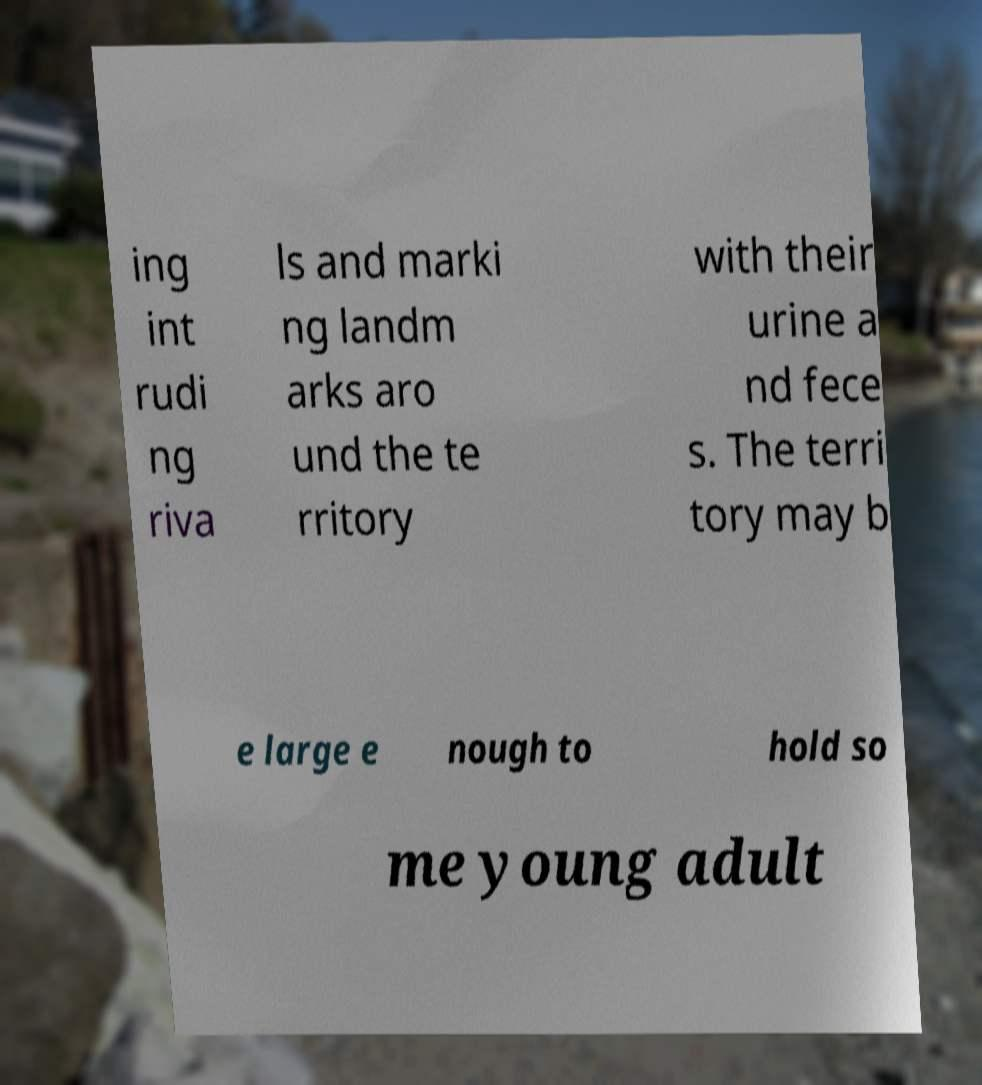What messages or text are displayed in this image? I need them in a readable, typed format. ing int rudi ng riva ls and marki ng landm arks aro und the te rritory with their urine a nd fece s. The terri tory may b e large e nough to hold so me young adult 